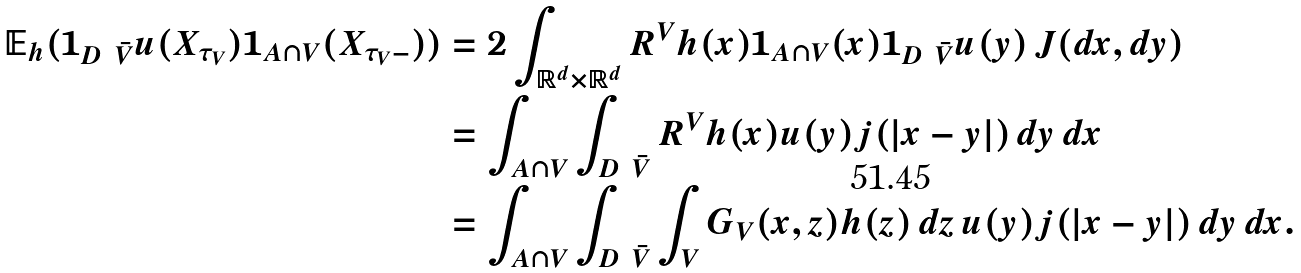Convert formula to latex. <formula><loc_0><loc_0><loc_500><loc_500>\mathbb { E } _ { h } ( \mathbf 1 _ { D \ \bar { V } } u ( X _ { \tau _ { V } } ) \mathbf 1 _ { A \cap V } ( X _ { \tau _ { V } - } ) ) & = 2 \int _ { \mathbb { R } ^ { d } \times \mathbb { R } ^ { d } } R ^ { V } h ( x ) \mathbf 1 _ { A \cap V } ( x ) \mathbf 1 _ { D \ \bar { V } } u ( y ) \, J ( d x , d y ) \\ & = \int _ { A \cap V } \int _ { D \ \bar { V } } R ^ { V } h ( x ) u ( y ) j ( | x - y | ) \, d y \, d x \\ & = \int _ { A \cap V } \int _ { D \ \bar { V } } \int _ { V } G _ { V } ( x , z ) h ( z ) \, d z \, u ( y ) j ( | x - y | ) \, d y \, d x .</formula> 